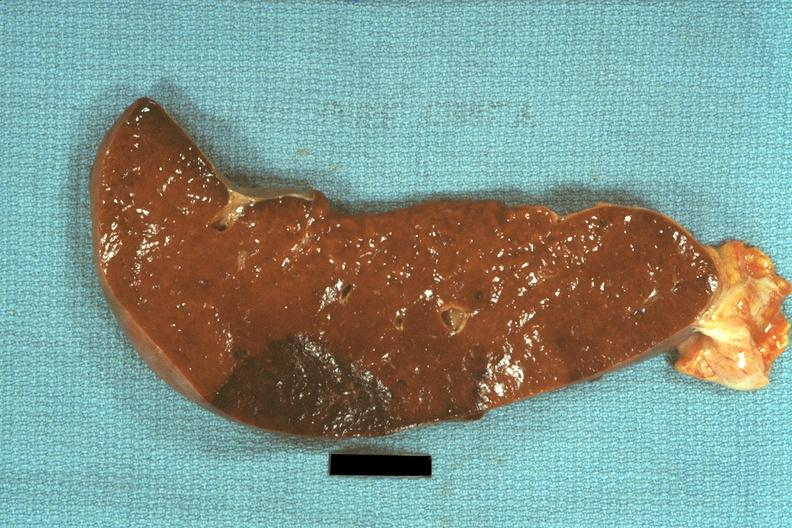s atheromatous embolus present?
Answer the question using a single word or phrase. No 